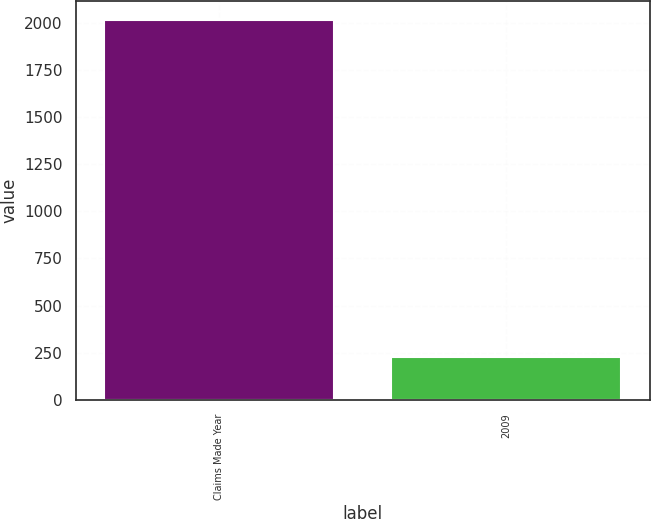Convert chart. <chart><loc_0><loc_0><loc_500><loc_500><bar_chart><fcel>Claims Made Year<fcel>2009<nl><fcel>2014<fcel>226<nl></chart> 